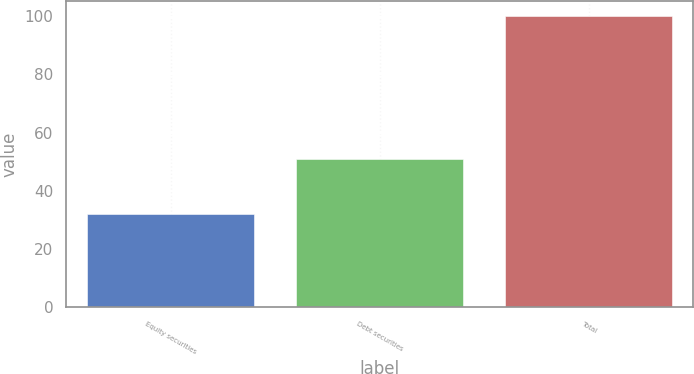Convert chart to OTSL. <chart><loc_0><loc_0><loc_500><loc_500><bar_chart><fcel>Equity securities<fcel>Debt securities<fcel>Total<nl><fcel>32<fcel>51<fcel>100<nl></chart> 